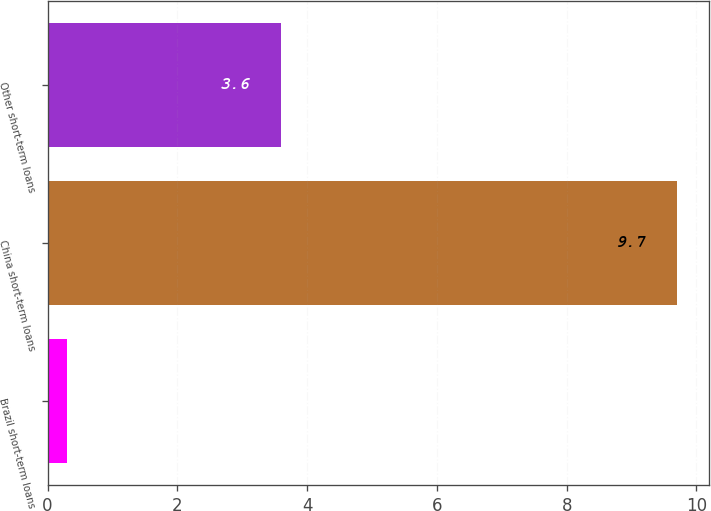<chart> <loc_0><loc_0><loc_500><loc_500><bar_chart><fcel>Brazil short-term loans<fcel>China short-term loans<fcel>Other short-term loans<nl><fcel>0.3<fcel>9.7<fcel>3.6<nl></chart> 